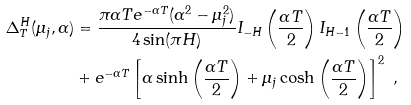<formula> <loc_0><loc_0><loc_500><loc_500>\Delta _ { T } ^ { H } ( \mu _ { j } , \alpha ) & = \frac { \pi \alpha T e ^ { - \alpha T } ( \alpha ^ { 2 } - \mu _ { j } ^ { 2 } ) } { 4 \sin ( \pi H ) } I _ { - H } \left ( \frac { \alpha T } { 2 } \right ) I _ { H - 1 } \left ( \frac { \alpha T } { 2 } \right ) \\ & + e ^ { - \alpha T } \left [ \alpha \sinh \left ( \frac { \alpha T } { 2 } \right ) + \mu _ { j } \cosh \left ( \frac { \alpha T } { 2 } \right ) \right ] ^ { 2 } \ ,</formula> 